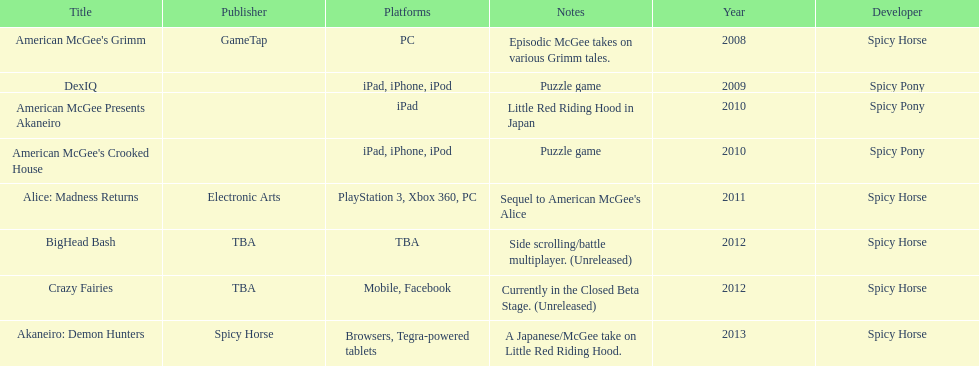What is the first title on this chart? American McGee's Grimm. Could you parse the entire table? {'header': ['Title', 'Publisher', 'Platforms', 'Notes', 'Year', 'Developer'], 'rows': [["American McGee's Grimm", 'GameTap', 'PC', 'Episodic McGee takes on various Grimm tales.', '2008', 'Spicy Horse'], ['DexIQ', '', 'iPad, iPhone, iPod', 'Puzzle game', '2009', 'Spicy Pony'], ['American McGee Presents Akaneiro', '', 'iPad', 'Little Red Riding Hood in Japan', '2010', 'Spicy Pony'], ["American McGee's Crooked House", '', 'iPad, iPhone, iPod', 'Puzzle game', '2010', 'Spicy Pony'], ['Alice: Madness Returns', 'Electronic Arts', 'PlayStation 3, Xbox 360, PC', "Sequel to American McGee's Alice", '2011', 'Spicy Horse'], ['BigHead Bash', 'TBA', 'TBA', 'Side scrolling/battle multiplayer. (Unreleased)', '2012', 'Spicy Horse'], ['Crazy Fairies', 'TBA', 'Mobile, Facebook', 'Currently in the Closed Beta Stage. (Unreleased)', '2012', 'Spicy Horse'], ['Akaneiro: Demon Hunters', 'Spicy Horse', 'Browsers, Tegra-powered tablets', 'A Japanese/McGee take on Little Red Riding Hood.', '2013', 'Spicy Horse']]} 